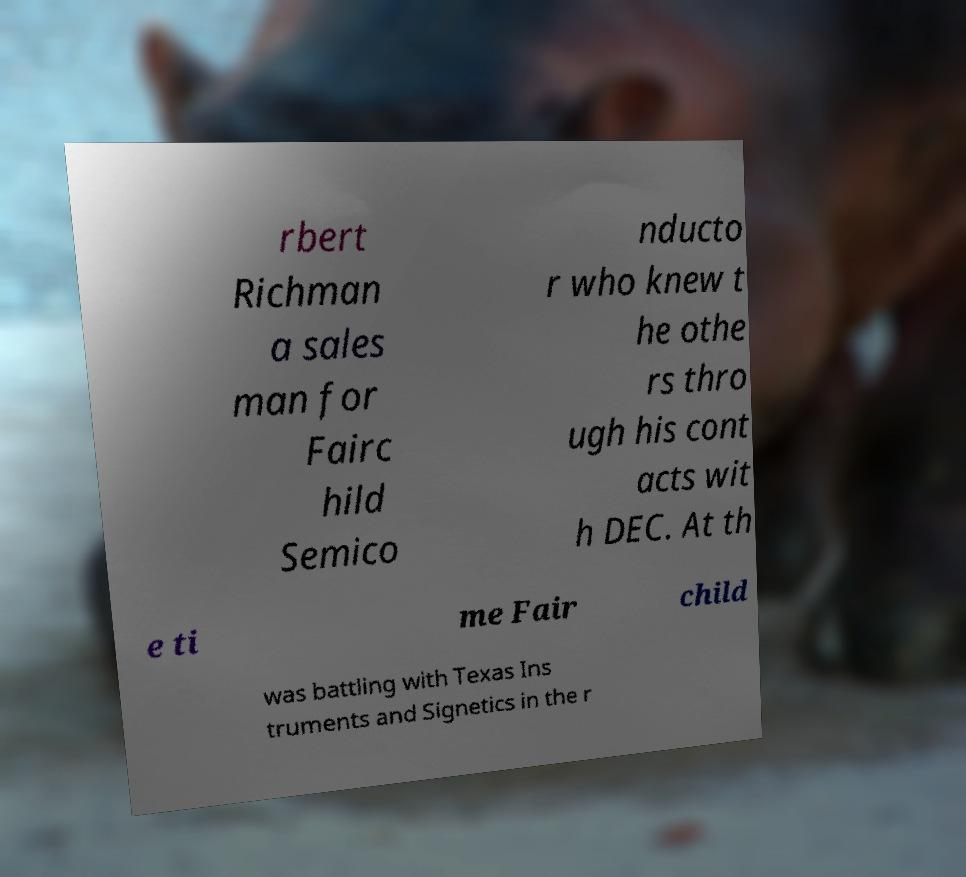What messages or text are displayed in this image? I need them in a readable, typed format. rbert Richman a sales man for Fairc hild Semico nducto r who knew t he othe rs thro ugh his cont acts wit h DEC. At th e ti me Fair child was battling with Texas Ins truments and Signetics in the r 